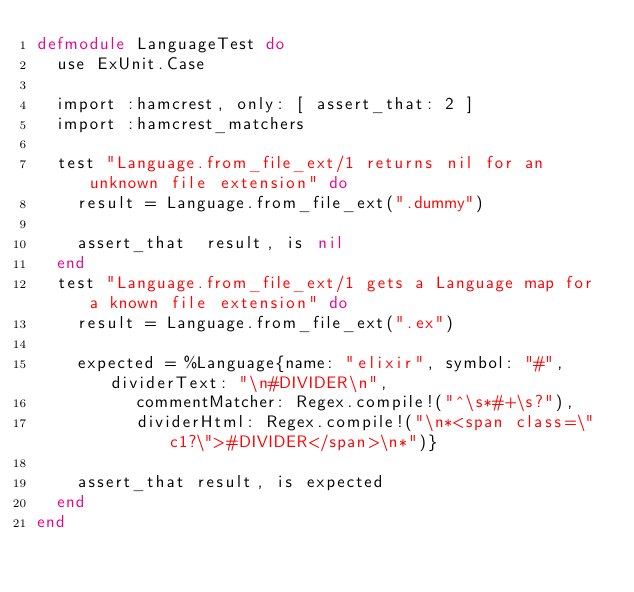<code> <loc_0><loc_0><loc_500><loc_500><_Elixir_>defmodule LanguageTest do
  use ExUnit.Case

  import :hamcrest, only: [ assert_that: 2 ]
  import :hamcrest_matchers

  test "Language.from_file_ext/1 returns nil for an unknown file extension" do
    result = Language.from_file_ext(".dummy")
    
    assert_that  result, is nil
  end
  test "Language.from_file_ext/1 gets a Language map for a known file extension" do
    result = Language.from_file_ext(".ex")
    
    expected = %Language{name: "elixir", symbol: "#", dividerText: "\n#DIVIDER\n",
          commentMatcher: Regex.compile!("^\s*#+\s?"),
          dividerHtml: Regex.compile!("\n*<span class=\"c1?\">#DIVIDER</span>\n*")}

    assert_that result, is expected
  end
end
</code> 